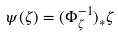<formula> <loc_0><loc_0><loc_500><loc_500>\psi ( \zeta ) = ( \Phi _ { \zeta } ^ { - 1 } ) _ { \ast } \zeta</formula> 